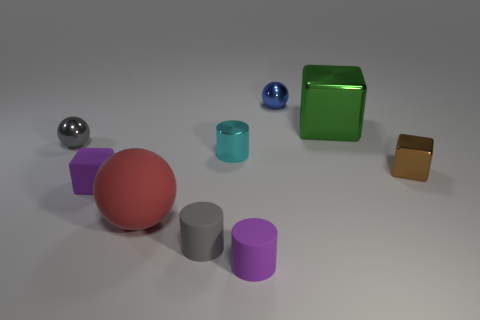How many objects are tiny purple objects in front of the purple block or metallic objects that are in front of the cyan metallic thing?
Ensure brevity in your answer.  2. What is the material of the gray thing on the right side of the gray thing that is left of the purple rubber thing behind the gray rubber object?
Provide a succinct answer. Rubber. There is a large thing behind the small brown metallic object; is its color the same as the large matte object?
Keep it short and to the point. No. There is a object that is both left of the metal cylinder and in front of the large sphere; what is its material?
Ensure brevity in your answer.  Rubber. Is there a gray matte cylinder that has the same size as the purple cylinder?
Offer a terse response. Yes. How many large rubber balls are there?
Provide a short and direct response. 1. There is a purple cylinder; how many red objects are to the right of it?
Your answer should be very brief. 0. Is the brown block made of the same material as the tiny blue object?
Ensure brevity in your answer.  Yes. How many objects are both behind the tiny gray shiny ball and in front of the brown cube?
Provide a succinct answer. 0. What number of other objects are the same color as the matte cube?
Ensure brevity in your answer.  1. 